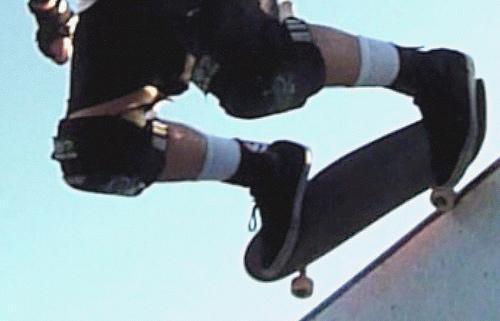How many feet are on the skateboard?
Give a very brief answer. 2. 